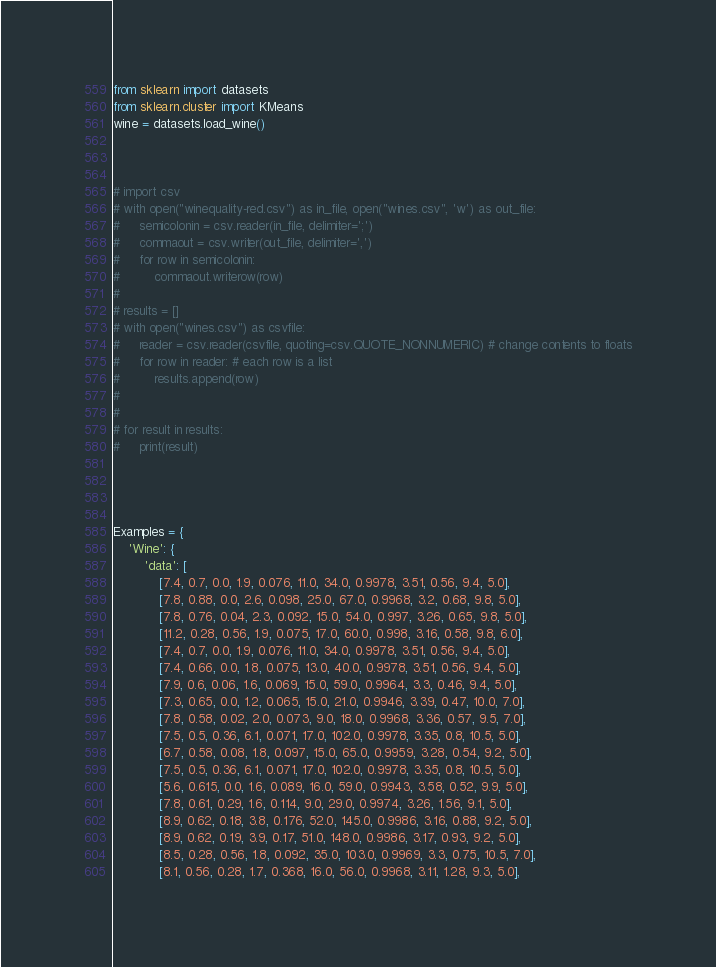<code> <loc_0><loc_0><loc_500><loc_500><_Python_>from sklearn import datasets
from sklearn.cluster import KMeans
wine = datasets.load_wine()



# import csv
# with open("winequality-red.csv") as in_file, open("wines.csv", 'w') as out_file:
#     semicolonin = csv.reader(in_file, delimiter=';')
#     commaout = csv.writer(out_file, delimiter=',')
#     for row in semicolonin:
#         commaout.writerow(row)
#
# results = []
# with open("wines.csv") as csvfile:
#     reader = csv.reader(csvfile, quoting=csv.QUOTE_NONNUMERIC) # change contents to floats
#     for row in reader: # each row is a list
#         results.append(row)
#
#
# for result in results:
#     print(result)




Examples = {
    'Wine': {
        'data': [
            [7.4, 0.7, 0.0, 1.9, 0.076, 11.0, 34.0, 0.9978, 3.51, 0.56, 9.4, 5.0],
            [7.8, 0.88, 0.0, 2.6, 0.098, 25.0, 67.0, 0.9968, 3.2, 0.68, 9.8, 5.0],
            [7.8, 0.76, 0.04, 2.3, 0.092, 15.0, 54.0, 0.997, 3.26, 0.65, 9.8, 5.0],
            [11.2, 0.28, 0.56, 1.9, 0.075, 17.0, 60.0, 0.998, 3.16, 0.58, 9.8, 6.0],
            [7.4, 0.7, 0.0, 1.9, 0.076, 11.0, 34.0, 0.9978, 3.51, 0.56, 9.4, 5.0],
            [7.4, 0.66, 0.0, 1.8, 0.075, 13.0, 40.0, 0.9978, 3.51, 0.56, 9.4, 5.0],
            [7.9, 0.6, 0.06, 1.6, 0.069, 15.0, 59.0, 0.9964, 3.3, 0.46, 9.4, 5.0],
            [7.3, 0.65, 0.0, 1.2, 0.065, 15.0, 21.0, 0.9946, 3.39, 0.47, 10.0, 7.0],
            [7.8, 0.58, 0.02, 2.0, 0.073, 9.0, 18.0, 0.9968, 3.36, 0.57, 9.5, 7.0],
            [7.5, 0.5, 0.36, 6.1, 0.071, 17.0, 102.0, 0.9978, 3.35, 0.8, 10.5, 5.0],
            [6.7, 0.58, 0.08, 1.8, 0.097, 15.0, 65.0, 0.9959, 3.28, 0.54, 9.2, 5.0],
            [7.5, 0.5, 0.36, 6.1, 0.071, 17.0, 102.0, 0.9978, 3.35, 0.8, 10.5, 5.0],
            [5.6, 0.615, 0.0, 1.6, 0.089, 16.0, 59.0, 0.9943, 3.58, 0.52, 9.9, 5.0],
            [7.8, 0.61, 0.29, 1.6, 0.114, 9.0, 29.0, 0.9974, 3.26, 1.56, 9.1, 5.0],
            [8.9, 0.62, 0.18, 3.8, 0.176, 52.0, 145.0, 0.9986, 3.16, 0.88, 9.2, 5.0],
            [8.9, 0.62, 0.19, 3.9, 0.17, 51.0, 148.0, 0.9986, 3.17, 0.93, 9.2, 5.0],
            [8.5, 0.28, 0.56, 1.8, 0.092, 35.0, 103.0, 0.9969, 3.3, 0.75, 10.5, 7.0],
            [8.1, 0.56, 0.28, 1.7, 0.368, 16.0, 56.0, 0.9968, 3.11, 1.28, 9.3, 5.0],</code> 